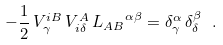Convert formula to latex. <formula><loc_0><loc_0><loc_500><loc_500>- \frac { 1 } { 2 } \, V ^ { i B } _ { \gamma } \, V ^ { A } _ { i \delta } \, { L _ { A B } } ^ { \alpha \beta } = \delta ^ { \alpha } _ { \gamma } \, \delta ^ { \beta } _ { \delta } \ .</formula> 